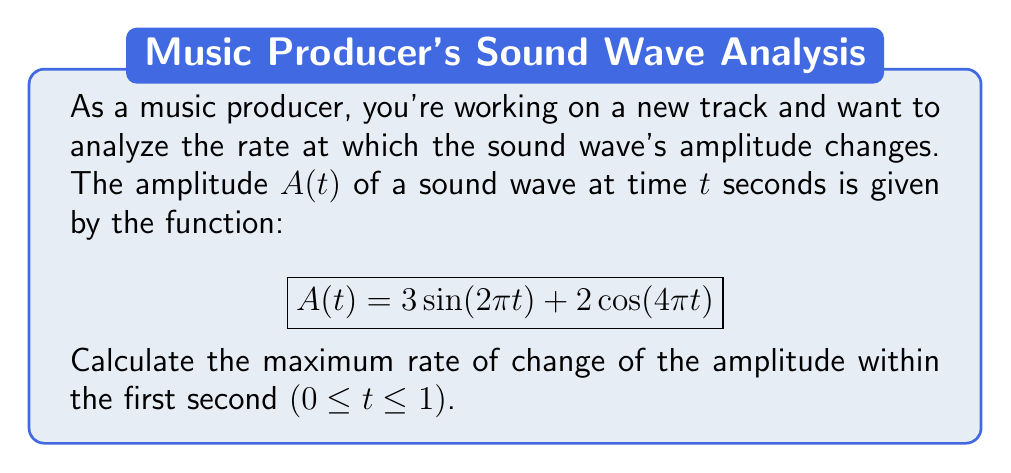Provide a solution to this math problem. To solve this problem, we'll follow these steps:

1) First, we need to find the rate of change of the amplitude. This is given by the derivative of $A(t)$ with respect to $t$. Let's call this $A'(t)$.

   $$A'(t) = \frac{d}{dt}[3\sin(2\pi t) + 2\cos(4\pi t)]$$

2) Using the chain rule and derivative rules for sine and cosine:

   $$A'(t) = 3(2\pi)\cos(2\pi t) + 2(-4\pi)\sin(4\pi t)$$
   $$A'(t) = 6\pi\cos(2\pi t) - 8\pi\sin(4\pi t)$$

3) The rate of change varies with time. To find the maximum rate of change, we need to find the maximum absolute value of $A'(t)$ within the given interval.

4) The maximum value of $\cos(2\pi t)$ is 1, and the maximum value of $\sin(4\pi t)$ is also 1. Therefore, the maximum possible value of $A'(t)$ occurs when these terms align to give the largest possible sum:

   $$|A'(t)_{max}| = |6\pi(1) + 8\pi(1)| = 14\pi$$

5) Similarly, the minimum possible value occurs when:

   $$|A'(t)_{min}| = |-6\pi(1) - 8\pi(1)| = 14\pi$$

6) The maximum rate of change is the larger of these two absolute values, which in this case are equal.

Therefore, the maximum rate of change of the amplitude within the first second is $14\pi$ units per second.
Answer: $14\pi$ units per second 